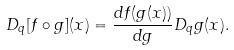Convert formula to latex. <formula><loc_0><loc_0><loc_500><loc_500>D _ { q } [ f \circ g ] ( x ) = \frac { d f ( g ( x ) ) } { d g } D _ { q } g ( x ) .</formula> 